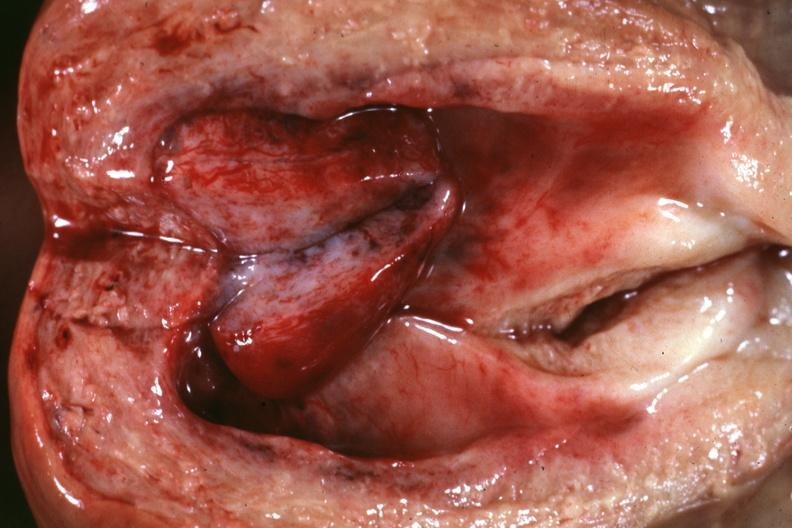s endometrial polyp present?
Answer the question using a single word or phrase. Yes 